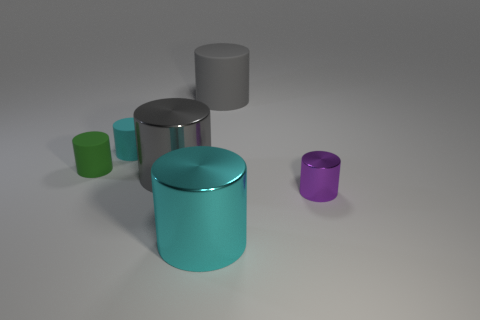How many objects are there in total in the image? There are five objects in the image, each differing in size and color. 